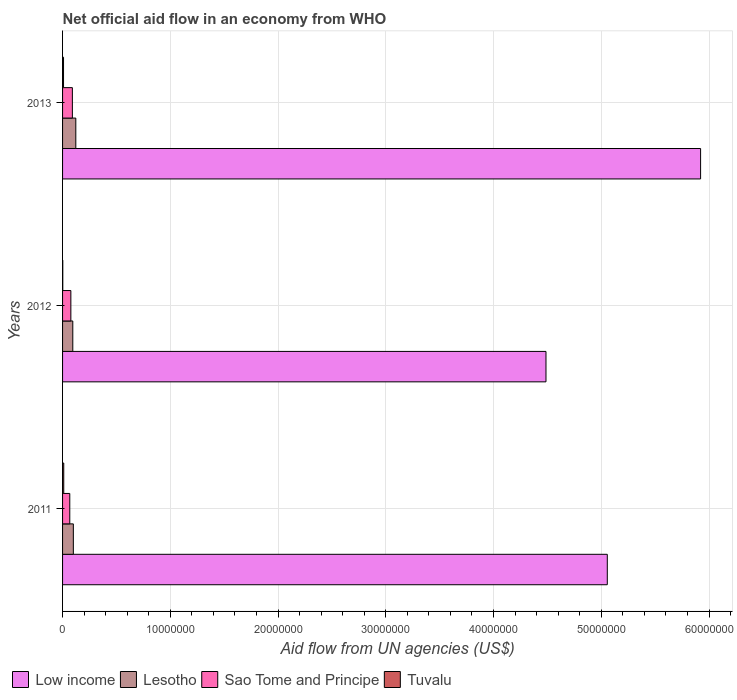How many groups of bars are there?
Give a very brief answer. 3. Are the number of bars per tick equal to the number of legend labels?
Keep it short and to the point. Yes. How many bars are there on the 1st tick from the top?
Your answer should be compact. 4. How many bars are there on the 1st tick from the bottom?
Your answer should be compact. 4. What is the label of the 3rd group of bars from the top?
Offer a terse response. 2011. In how many cases, is the number of bars for a given year not equal to the number of legend labels?
Provide a succinct answer. 0. What is the net official aid flow in Low income in 2011?
Your answer should be very brief. 5.06e+07. Across all years, what is the maximum net official aid flow in Tuvalu?
Offer a very short reply. 1.10e+05. Across all years, what is the minimum net official aid flow in Lesotho?
Offer a very short reply. 9.50e+05. In which year was the net official aid flow in Sao Tome and Principe maximum?
Offer a very short reply. 2013. In which year was the net official aid flow in Tuvalu minimum?
Offer a very short reply. 2012. What is the total net official aid flow in Lesotho in the graph?
Offer a very short reply. 3.18e+06. What is the difference between the net official aid flow in Sao Tome and Principe in 2012 and that in 2013?
Your response must be concise. -1.40e+05. What is the difference between the net official aid flow in Tuvalu in 2013 and the net official aid flow in Low income in 2012?
Your response must be concise. -4.48e+07. What is the average net official aid flow in Tuvalu per year?
Your answer should be compact. 7.33e+04. In the year 2011, what is the difference between the net official aid flow in Low income and net official aid flow in Lesotho?
Make the answer very short. 4.96e+07. In how many years, is the net official aid flow in Low income greater than 4000000 US$?
Make the answer very short. 3. What is the ratio of the net official aid flow in Low income in 2011 to that in 2013?
Offer a very short reply. 0.85. In how many years, is the net official aid flow in Low income greater than the average net official aid flow in Low income taken over all years?
Provide a succinct answer. 1. Is the sum of the net official aid flow in Low income in 2011 and 2013 greater than the maximum net official aid flow in Sao Tome and Principe across all years?
Provide a short and direct response. Yes. Is it the case that in every year, the sum of the net official aid flow in Lesotho and net official aid flow in Tuvalu is greater than the sum of net official aid flow in Sao Tome and Principe and net official aid flow in Low income?
Your answer should be compact. No. What does the 3rd bar from the top in 2013 represents?
Offer a terse response. Lesotho. How many bars are there?
Provide a short and direct response. 12. Are the values on the major ticks of X-axis written in scientific E-notation?
Provide a short and direct response. No. Does the graph contain any zero values?
Provide a short and direct response. No. How many legend labels are there?
Your answer should be very brief. 4. What is the title of the graph?
Keep it short and to the point. Net official aid flow in an economy from WHO. What is the label or title of the X-axis?
Your response must be concise. Aid flow from UN agencies (US$). What is the label or title of the Y-axis?
Keep it short and to the point. Years. What is the Aid flow from UN agencies (US$) of Low income in 2011?
Provide a short and direct response. 5.06e+07. What is the Aid flow from UN agencies (US$) in Lesotho in 2011?
Offer a very short reply. 1.00e+06. What is the Aid flow from UN agencies (US$) in Sao Tome and Principe in 2011?
Offer a terse response. 6.70e+05. What is the Aid flow from UN agencies (US$) in Low income in 2012?
Provide a succinct answer. 4.49e+07. What is the Aid flow from UN agencies (US$) in Lesotho in 2012?
Offer a terse response. 9.50e+05. What is the Aid flow from UN agencies (US$) in Sao Tome and Principe in 2012?
Your answer should be very brief. 7.70e+05. What is the Aid flow from UN agencies (US$) of Tuvalu in 2012?
Your answer should be very brief. 2.00e+04. What is the Aid flow from UN agencies (US$) in Low income in 2013?
Offer a terse response. 5.92e+07. What is the Aid flow from UN agencies (US$) of Lesotho in 2013?
Offer a terse response. 1.23e+06. What is the Aid flow from UN agencies (US$) of Sao Tome and Principe in 2013?
Ensure brevity in your answer.  9.10e+05. Across all years, what is the maximum Aid flow from UN agencies (US$) of Low income?
Your response must be concise. 5.92e+07. Across all years, what is the maximum Aid flow from UN agencies (US$) of Lesotho?
Your answer should be compact. 1.23e+06. Across all years, what is the maximum Aid flow from UN agencies (US$) of Sao Tome and Principe?
Keep it short and to the point. 9.10e+05. Across all years, what is the minimum Aid flow from UN agencies (US$) of Low income?
Provide a short and direct response. 4.49e+07. Across all years, what is the minimum Aid flow from UN agencies (US$) of Lesotho?
Make the answer very short. 9.50e+05. Across all years, what is the minimum Aid flow from UN agencies (US$) in Sao Tome and Principe?
Provide a short and direct response. 6.70e+05. Across all years, what is the minimum Aid flow from UN agencies (US$) of Tuvalu?
Provide a succinct answer. 2.00e+04. What is the total Aid flow from UN agencies (US$) of Low income in the graph?
Your response must be concise. 1.55e+08. What is the total Aid flow from UN agencies (US$) in Lesotho in the graph?
Offer a very short reply. 3.18e+06. What is the total Aid flow from UN agencies (US$) of Sao Tome and Principe in the graph?
Ensure brevity in your answer.  2.35e+06. What is the total Aid flow from UN agencies (US$) in Tuvalu in the graph?
Offer a terse response. 2.20e+05. What is the difference between the Aid flow from UN agencies (US$) in Low income in 2011 and that in 2012?
Your answer should be compact. 5.69e+06. What is the difference between the Aid flow from UN agencies (US$) of Sao Tome and Principe in 2011 and that in 2012?
Provide a succinct answer. -1.00e+05. What is the difference between the Aid flow from UN agencies (US$) of Low income in 2011 and that in 2013?
Keep it short and to the point. -8.66e+06. What is the difference between the Aid flow from UN agencies (US$) in Sao Tome and Principe in 2011 and that in 2013?
Keep it short and to the point. -2.40e+05. What is the difference between the Aid flow from UN agencies (US$) of Low income in 2012 and that in 2013?
Your answer should be compact. -1.44e+07. What is the difference between the Aid flow from UN agencies (US$) in Lesotho in 2012 and that in 2013?
Offer a very short reply. -2.80e+05. What is the difference between the Aid flow from UN agencies (US$) in Low income in 2011 and the Aid flow from UN agencies (US$) in Lesotho in 2012?
Your response must be concise. 4.96e+07. What is the difference between the Aid flow from UN agencies (US$) of Low income in 2011 and the Aid flow from UN agencies (US$) of Sao Tome and Principe in 2012?
Give a very brief answer. 4.98e+07. What is the difference between the Aid flow from UN agencies (US$) in Low income in 2011 and the Aid flow from UN agencies (US$) in Tuvalu in 2012?
Your answer should be very brief. 5.05e+07. What is the difference between the Aid flow from UN agencies (US$) in Lesotho in 2011 and the Aid flow from UN agencies (US$) in Sao Tome and Principe in 2012?
Make the answer very short. 2.30e+05. What is the difference between the Aid flow from UN agencies (US$) of Lesotho in 2011 and the Aid flow from UN agencies (US$) of Tuvalu in 2012?
Give a very brief answer. 9.80e+05. What is the difference between the Aid flow from UN agencies (US$) in Sao Tome and Principe in 2011 and the Aid flow from UN agencies (US$) in Tuvalu in 2012?
Your response must be concise. 6.50e+05. What is the difference between the Aid flow from UN agencies (US$) of Low income in 2011 and the Aid flow from UN agencies (US$) of Lesotho in 2013?
Provide a short and direct response. 4.93e+07. What is the difference between the Aid flow from UN agencies (US$) in Low income in 2011 and the Aid flow from UN agencies (US$) in Sao Tome and Principe in 2013?
Give a very brief answer. 4.96e+07. What is the difference between the Aid flow from UN agencies (US$) in Low income in 2011 and the Aid flow from UN agencies (US$) in Tuvalu in 2013?
Offer a terse response. 5.05e+07. What is the difference between the Aid flow from UN agencies (US$) of Lesotho in 2011 and the Aid flow from UN agencies (US$) of Sao Tome and Principe in 2013?
Offer a terse response. 9.00e+04. What is the difference between the Aid flow from UN agencies (US$) in Lesotho in 2011 and the Aid flow from UN agencies (US$) in Tuvalu in 2013?
Keep it short and to the point. 9.10e+05. What is the difference between the Aid flow from UN agencies (US$) of Sao Tome and Principe in 2011 and the Aid flow from UN agencies (US$) of Tuvalu in 2013?
Offer a terse response. 5.80e+05. What is the difference between the Aid flow from UN agencies (US$) of Low income in 2012 and the Aid flow from UN agencies (US$) of Lesotho in 2013?
Offer a very short reply. 4.36e+07. What is the difference between the Aid flow from UN agencies (US$) of Low income in 2012 and the Aid flow from UN agencies (US$) of Sao Tome and Principe in 2013?
Your answer should be very brief. 4.40e+07. What is the difference between the Aid flow from UN agencies (US$) in Low income in 2012 and the Aid flow from UN agencies (US$) in Tuvalu in 2013?
Provide a succinct answer. 4.48e+07. What is the difference between the Aid flow from UN agencies (US$) of Lesotho in 2012 and the Aid flow from UN agencies (US$) of Sao Tome and Principe in 2013?
Offer a very short reply. 4.00e+04. What is the difference between the Aid flow from UN agencies (US$) in Lesotho in 2012 and the Aid flow from UN agencies (US$) in Tuvalu in 2013?
Keep it short and to the point. 8.60e+05. What is the difference between the Aid flow from UN agencies (US$) of Sao Tome and Principe in 2012 and the Aid flow from UN agencies (US$) of Tuvalu in 2013?
Your response must be concise. 6.80e+05. What is the average Aid flow from UN agencies (US$) in Low income per year?
Your answer should be very brief. 5.16e+07. What is the average Aid flow from UN agencies (US$) in Lesotho per year?
Offer a terse response. 1.06e+06. What is the average Aid flow from UN agencies (US$) in Sao Tome and Principe per year?
Make the answer very short. 7.83e+05. What is the average Aid flow from UN agencies (US$) of Tuvalu per year?
Your answer should be compact. 7.33e+04. In the year 2011, what is the difference between the Aid flow from UN agencies (US$) of Low income and Aid flow from UN agencies (US$) of Lesotho?
Keep it short and to the point. 4.96e+07. In the year 2011, what is the difference between the Aid flow from UN agencies (US$) in Low income and Aid flow from UN agencies (US$) in Sao Tome and Principe?
Your response must be concise. 4.99e+07. In the year 2011, what is the difference between the Aid flow from UN agencies (US$) of Low income and Aid flow from UN agencies (US$) of Tuvalu?
Your answer should be very brief. 5.04e+07. In the year 2011, what is the difference between the Aid flow from UN agencies (US$) of Lesotho and Aid flow from UN agencies (US$) of Tuvalu?
Your answer should be compact. 8.90e+05. In the year 2011, what is the difference between the Aid flow from UN agencies (US$) of Sao Tome and Principe and Aid flow from UN agencies (US$) of Tuvalu?
Offer a very short reply. 5.60e+05. In the year 2012, what is the difference between the Aid flow from UN agencies (US$) of Low income and Aid flow from UN agencies (US$) of Lesotho?
Offer a very short reply. 4.39e+07. In the year 2012, what is the difference between the Aid flow from UN agencies (US$) in Low income and Aid flow from UN agencies (US$) in Sao Tome and Principe?
Ensure brevity in your answer.  4.41e+07. In the year 2012, what is the difference between the Aid flow from UN agencies (US$) in Low income and Aid flow from UN agencies (US$) in Tuvalu?
Give a very brief answer. 4.48e+07. In the year 2012, what is the difference between the Aid flow from UN agencies (US$) in Lesotho and Aid flow from UN agencies (US$) in Tuvalu?
Provide a succinct answer. 9.30e+05. In the year 2012, what is the difference between the Aid flow from UN agencies (US$) of Sao Tome and Principe and Aid flow from UN agencies (US$) of Tuvalu?
Your answer should be very brief. 7.50e+05. In the year 2013, what is the difference between the Aid flow from UN agencies (US$) of Low income and Aid flow from UN agencies (US$) of Lesotho?
Offer a very short reply. 5.80e+07. In the year 2013, what is the difference between the Aid flow from UN agencies (US$) of Low income and Aid flow from UN agencies (US$) of Sao Tome and Principe?
Provide a short and direct response. 5.83e+07. In the year 2013, what is the difference between the Aid flow from UN agencies (US$) in Low income and Aid flow from UN agencies (US$) in Tuvalu?
Your answer should be very brief. 5.91e+07. In the year 2013, what is the difference between the Aid flow from UN agencies (US$) of Lesotho and Aid flow from UN agencies (US$) of Tuvalu?
Give a very brief answer. 1.14e+06. In the year 2013, what is the difference between the Aid flow from UN agencies (US$) in Sao Tome and Principe and Aid flow from UN agencies (US$) in Tuvalu?
Provide a short and direct response. 8.20e+05. What is the ratio of the Aid flow from UN agencies (US$) of Low income in 2011 to that in 2012?
Your answer should be compact. 1.13. What is the ratio of the Aid flow from UN agencies (US$) in Lesotho in 2011 to that in 2012?
Your answer should be very brief. 1.05. What is the ratio of the Aid flow from UN agencies (US$) of Sao Tome and Principe in 2011 to that in 2012?
Make the answer very short. 0.87. What is the ratio of the Aid flow from UN agencies (US$) of Low income in 2011 to that in 2013?
Offer a very short reply. 0.85. What is the ratio of the Aid flow from UN agencies (US$) of Lesotho in 2011 to that in 2013?
Your answer should be very brief. 0.81. What is the ratio of the Aid flow from UN agencies (US$) of Sao Tome and Principe in 2011 to that in 2013?
Keep it short and to the point. 0.74. What is the ratio of the Aid flow from UN agencies (US$) in Tuvalu in 2011 to that in 2013?
Offer a very short reply. 1.22. What is the ratio of the Aid flow from UN agencies (US$) of Low income in 2012 to that in 2013?
Provide a short and direct response. 0.76. What is the ratio of the Aid flow from UN agencies (US$) in Lesotho in 2012 to that in 2013?
Ensure brevity in your answer.  0.77. What is the ratio of the Aid flow from UN agencies (US$) of Sao Tome and Principe in 2012 to that in 2013?
Keep it short and to the point. 0.85. What is the ratio of the Aid flow from UN agencies (US$) of Tuvalu in 2012 to that in 2013?
Make the answer very short. 0.22. What is the difference between the highest and the second highest Aid flow from UN agencies (US$) of Low income?
Offer a very short reply. 8.66e+06. What is the difference between the highest and the second highest Aid flow from UN agencies (US$) in Lesotho?
Your response must be concise. 2.30e+05. What is the difference between the highest and the second highest Aid flow from UN agencies (US$) of Tuvalu?
Provide a short and direct response. 2.00e+04. What is the difference between the highest and the lowest Aid flow from UN agencies (US$) of Low income?
Your response must be concise. 1.44e+07. What is the difference between the highest and the lowest Aid flow from UN agencies (US$) of Tuvalu?
Ensure brevity in your answer.  9.00e+04. 